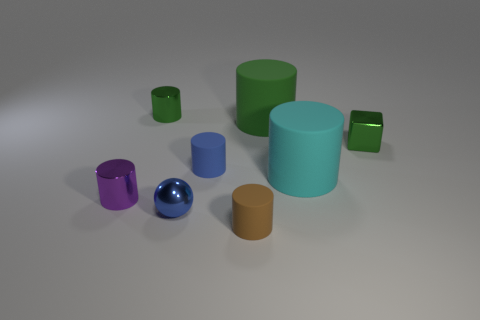What size is the metallic cylinder that is the same color as the small shiny block?
Your response must be concise. Small. What is the material of the tiny object that is the same color as the metal block?
Your answer should be compact. Metal. There is a matte cylinder that is behind the tiny shiny block; what is its size?
Offer a terse response. Large. How many things are either blue cylinders or tiny shiny things on the right side of the purple shiny cylinder?
Offer a very short reply. 4. What number of other things are the same size as the purple object?
Keep it short and to the point. 5. There is a blue thing that is the same shape as the small brown object; what material is it?
Your answer should be compact. Rubber. Are there more rubber objects behind the cyan matte object than tiny brown rubber cylinders?
Keep it short and to the point. Yes. Is there anything else that has the same color as the sphere?
Your response must be concise. Yes. The tiny green thing that is made of the same material as the cube is what shape?
Your answer should be very brief. Cylinder. Does the tiny blue thing that is behind the tiny purple thing have the same material as the large green cylinder?
Your response must be concise. Yes. 